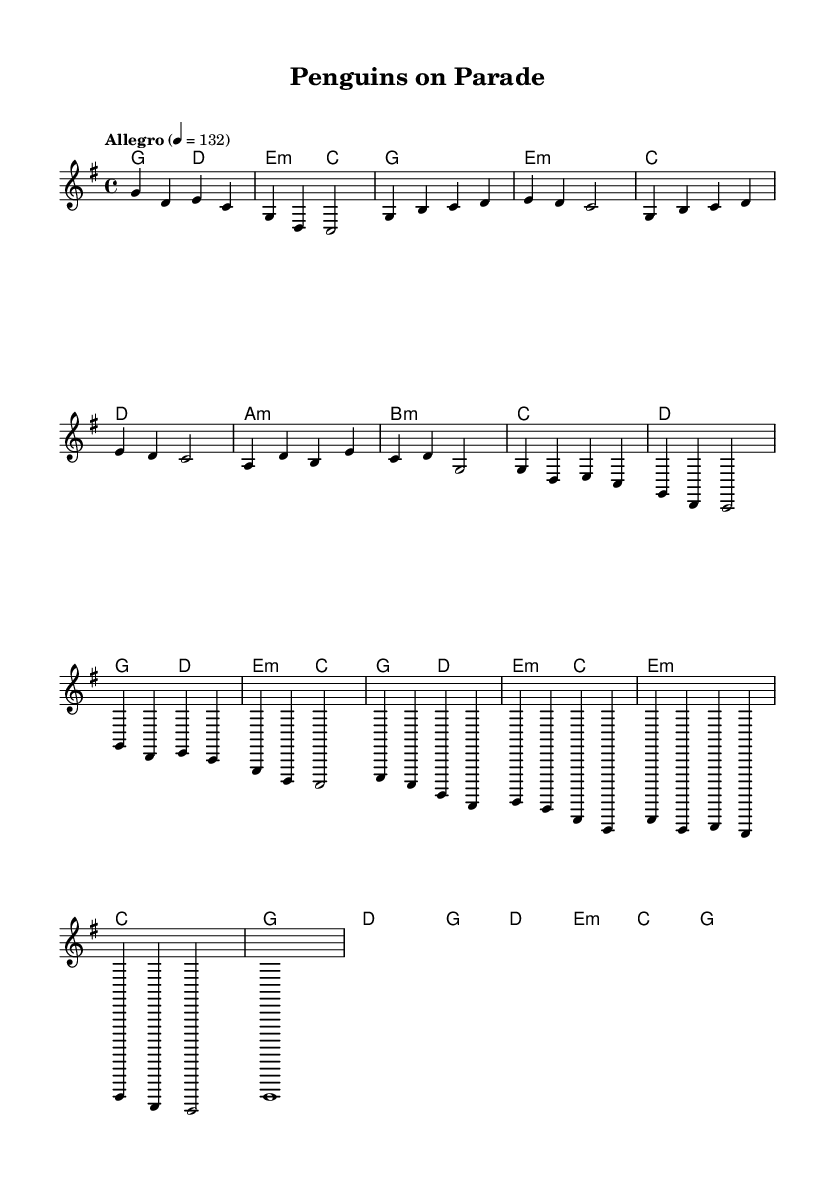What is the key signature of this music? The key signature indicated in the music is G major, which contains one sharp (F#).
Answer: G major What is the time signature of this piece? The time signature shown in the music is 4/4, meaning there are four beats per measure.
Answer: 4/4 What is the tempo marking for this piece? The tempo marking indicates an "Allegro" tempo, which is typically around 120-168 beats per minute. The specific marking here is set at 132 beats per minute.
Answer: Allegro 132 How many measures are in the chorus section? By examining the structure of the music, the chorus consists of four measures as denoted by the notation in the music.
Answer: 4 measures What is the first chord in the introduction? The first chord in the introduction is a G major chord, as indicated by the chord names in the score.
Answer: G What is the last note in the melody? The last note in the melody is a long whole note (g) that concludes the piece, as indicated by its notation at the end of the staff.
Answer: g What type of song structure is used in this piece? The structure of the piece follows a common pop format, which includes an introduction, verses, a pre-chorus, a chorus, a bridge, and an outro.
Answer: Verse-Chorus structure 